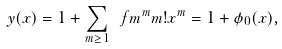Convert formula to latex. <formula><loc_0><loc_0><loc_500><loc_500>y ( x ) = 1 + \sum _ { m \geq 1 } \ f { m ^ { m } } { m ! } x ^ { m } = 1 + \phi _ { 0 } ( x ) ,</formula> 